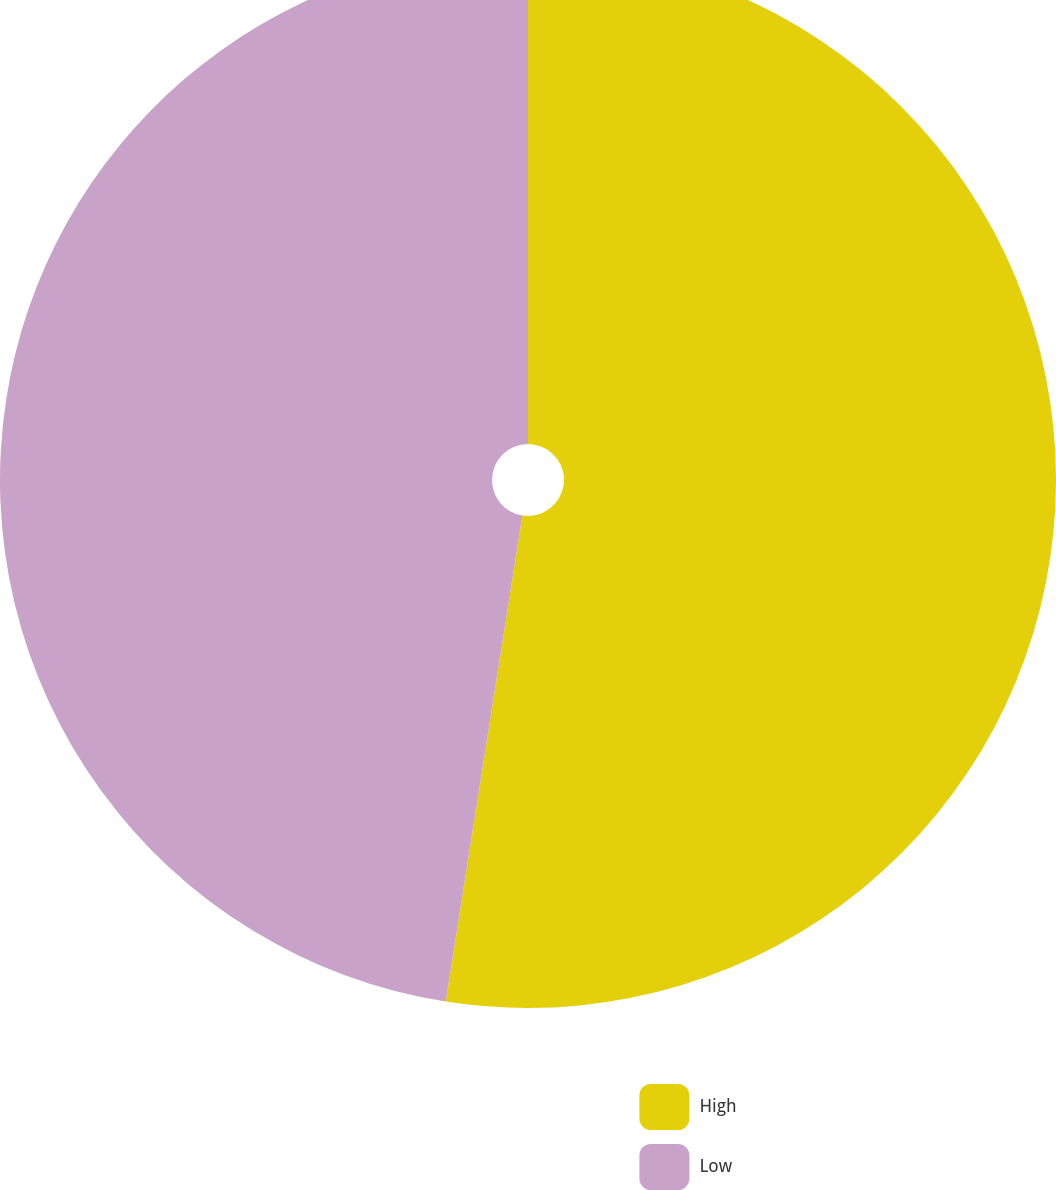Convert chart. <chart><loc_0><loc_0><loc_500><loc_500><pie_chart><fcel>High<fcel>Low<nl><fcel>52.49%<fcel>47.51%<nl></chart> 